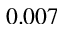<formula> <loc_0><loc_0><loc_500><loc_500>0 . 0 0 7</formula> 